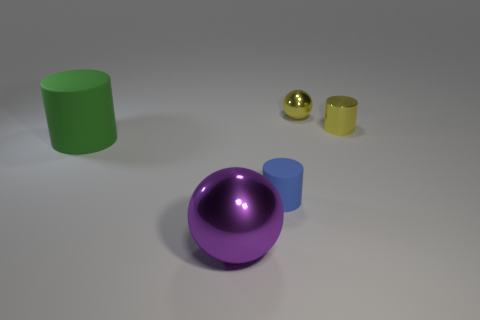Subtract 1 cylinders. How many cylinders are left? 2 Add 4 big metal balls. How many objects exist? 9 Subtract all spheres. How many objects are left? 3 Subtract all small yellow spheres. Subtract all tiny gray rubber cylinders. How many objects are left? 4 Add 5 small matte cylinders. How many small matte cylinders are left? 6 Add 3 red metal cylinders. How many red metal cylinders exist? 3 Subtract 0 purple cylinders. How many objects are left? 5 